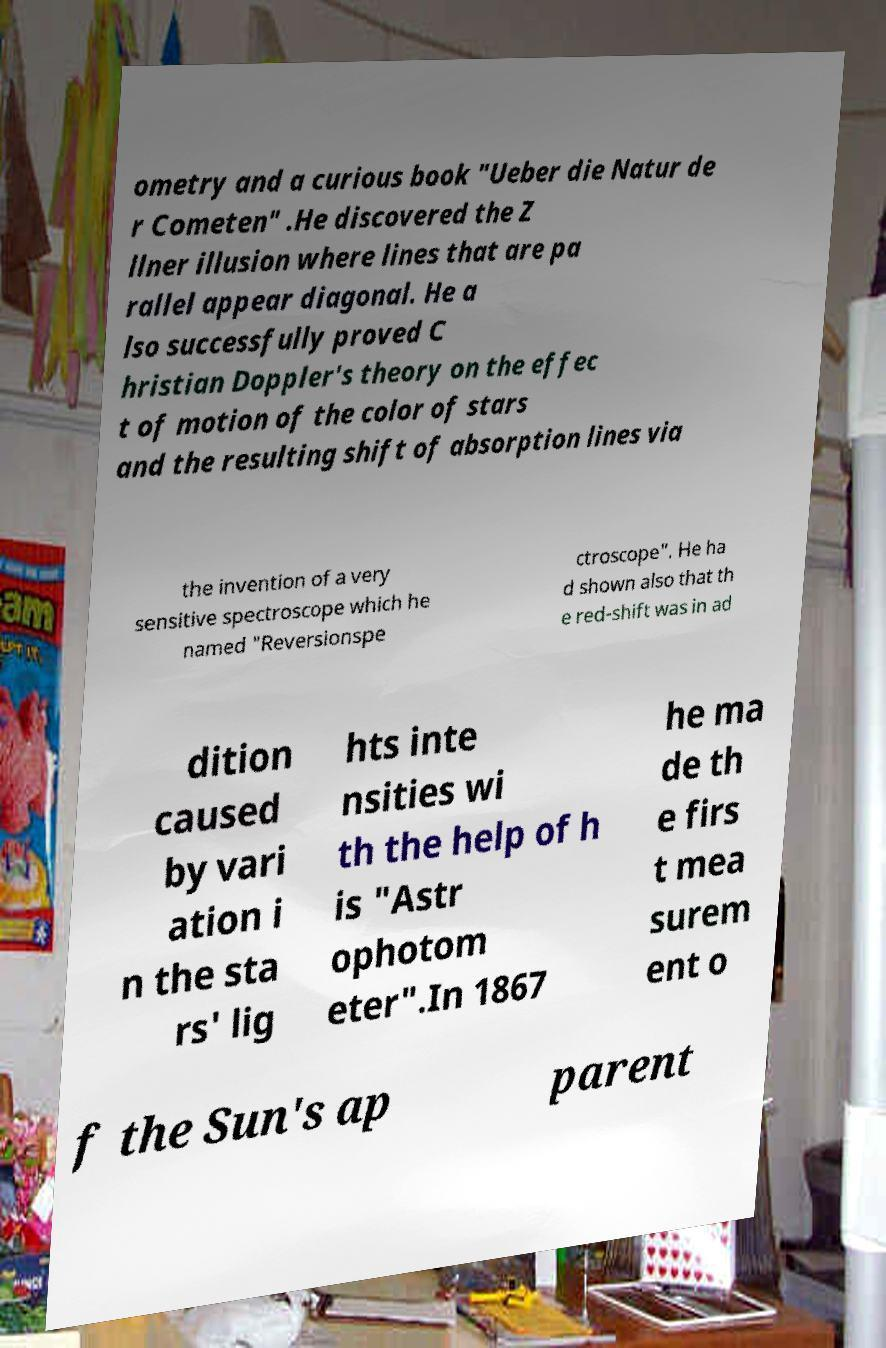Could you assist in decoding the text presented in this image and type it out clearly? ometry and a curious book "Ueber die Natur de r Cometen" .He discovered the Z llner illusion where lines that are pa rallel appear diagonal. He a lso successfully proved C hristian Doppler's theory on the effec t of motion of the color of stars and the resulting shift of absorption lines via the invention of a very sensitive spectroscope which he named "Reversionspe ctroscope". He ha d shown also that th e red-shift was in ad dition caused by vari ation i n the sta rs' lig hts inte nsities wi th the help of h is "Astr ophotom eter".In 1867 he ma de th e firs t mea surem ent o f the Sun's ap parent 